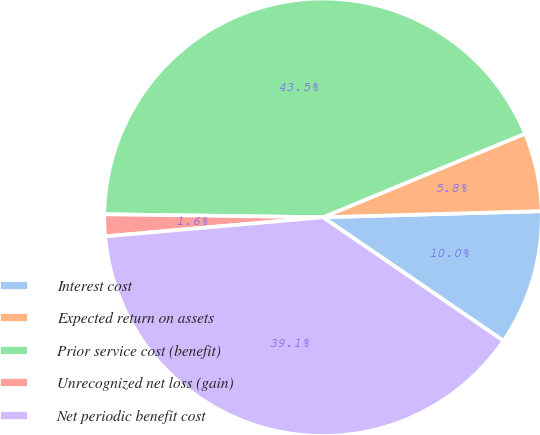Convert chart. <chart><loc_0><loc_0><loc_500><loc_500><pie_chart><fcel>Interest cost<fcel>Expected return on assets<fcel>Prior service cost (benefit)<fcel>Unrecognized net loss (gain)<fcel>Net periodic benefit cost<nl><fcel>10.0%<fcel>5.8%<fcel>43.53%<fcel>1.61%<fcel>39.05%<nl></chart> 